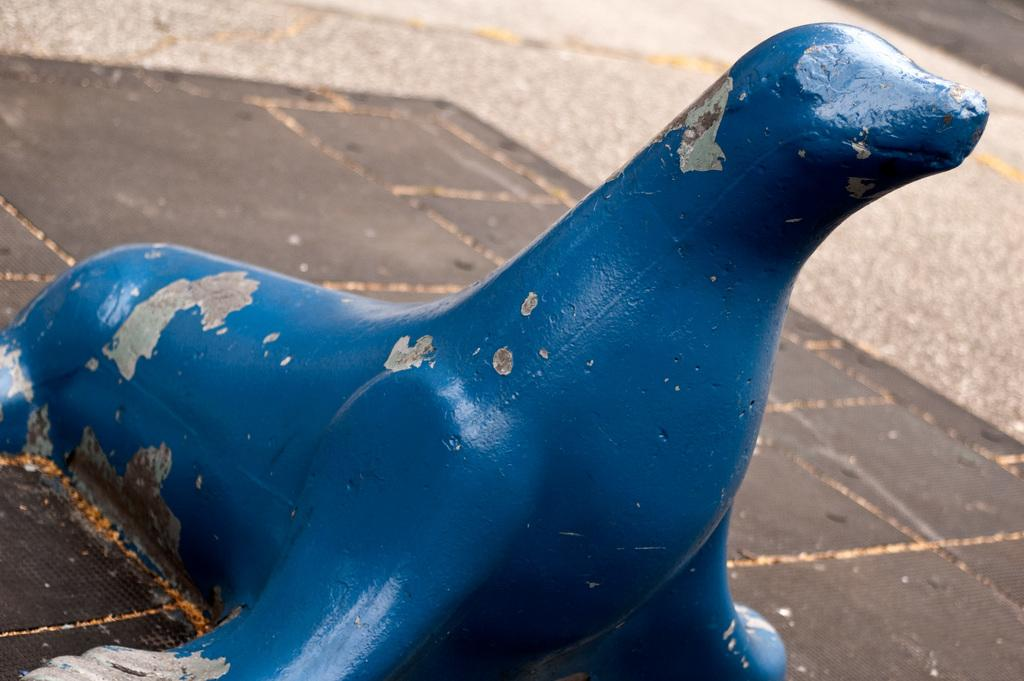What type of surface is visible in the image? There is a path with tiles in the image. What animal can be seen in the image? There is a sea lion in the image. What color is the sea lion? The sea lion is blue in color. What type of food is the sea lion eating from its mouth in the image? There is no food or mouth visible in the image; the sea lion is blue and does not have any visible features besides its color. 